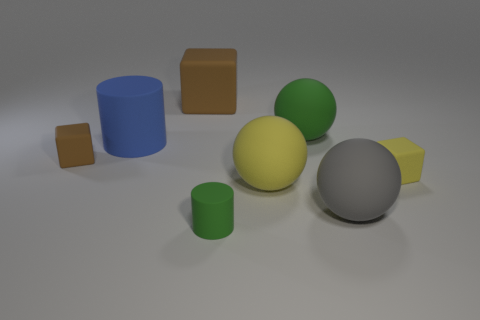Add 1 tiny cyan metallic objects. How many objects exist? 9 Subtract all balls. How many objects are left? 5 Add 4 balls. How many balls are left? 7 Add 4 large matte cylinders. How many large matte cylinders exist? 5 Subtract 1 gray balls. How many objects are left? 7 Subtract all brown blocks. Subtract all big brown matte blocks. How many objects are left? 5 